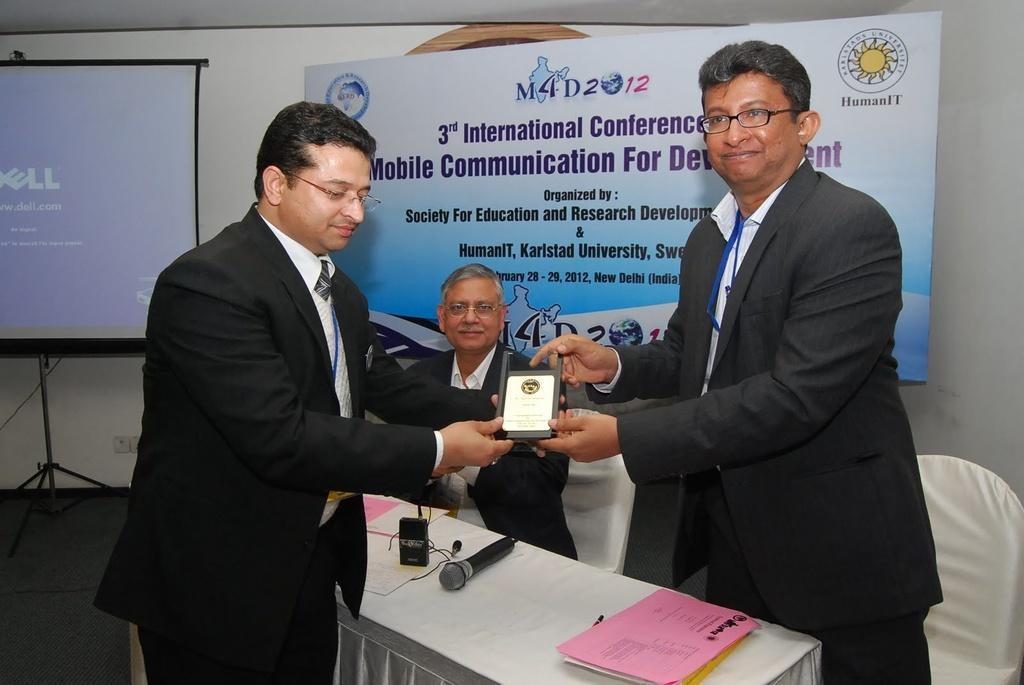Can you describe this image briefly? In this picture I can see a man seated and couple of them standing and holding a memento in their hands and I can see papers and a microphone on the table and I can see a board in the back with some text and a projector screen on the left side. 